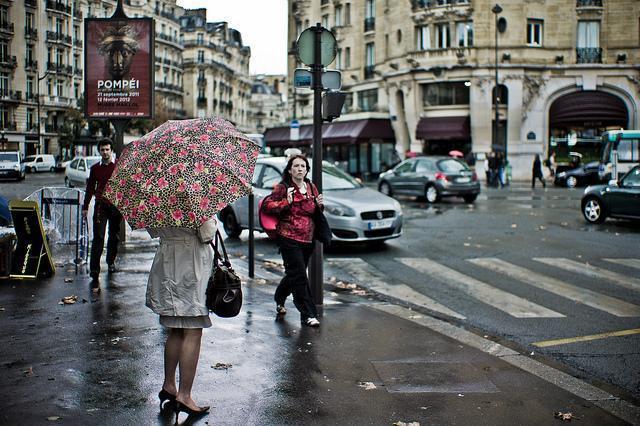When does the Pompeii exhibit end?
From the following four choices, select the correct answer to address the question.
Options: 2010, 2011, 2012, 2013. 2012. 